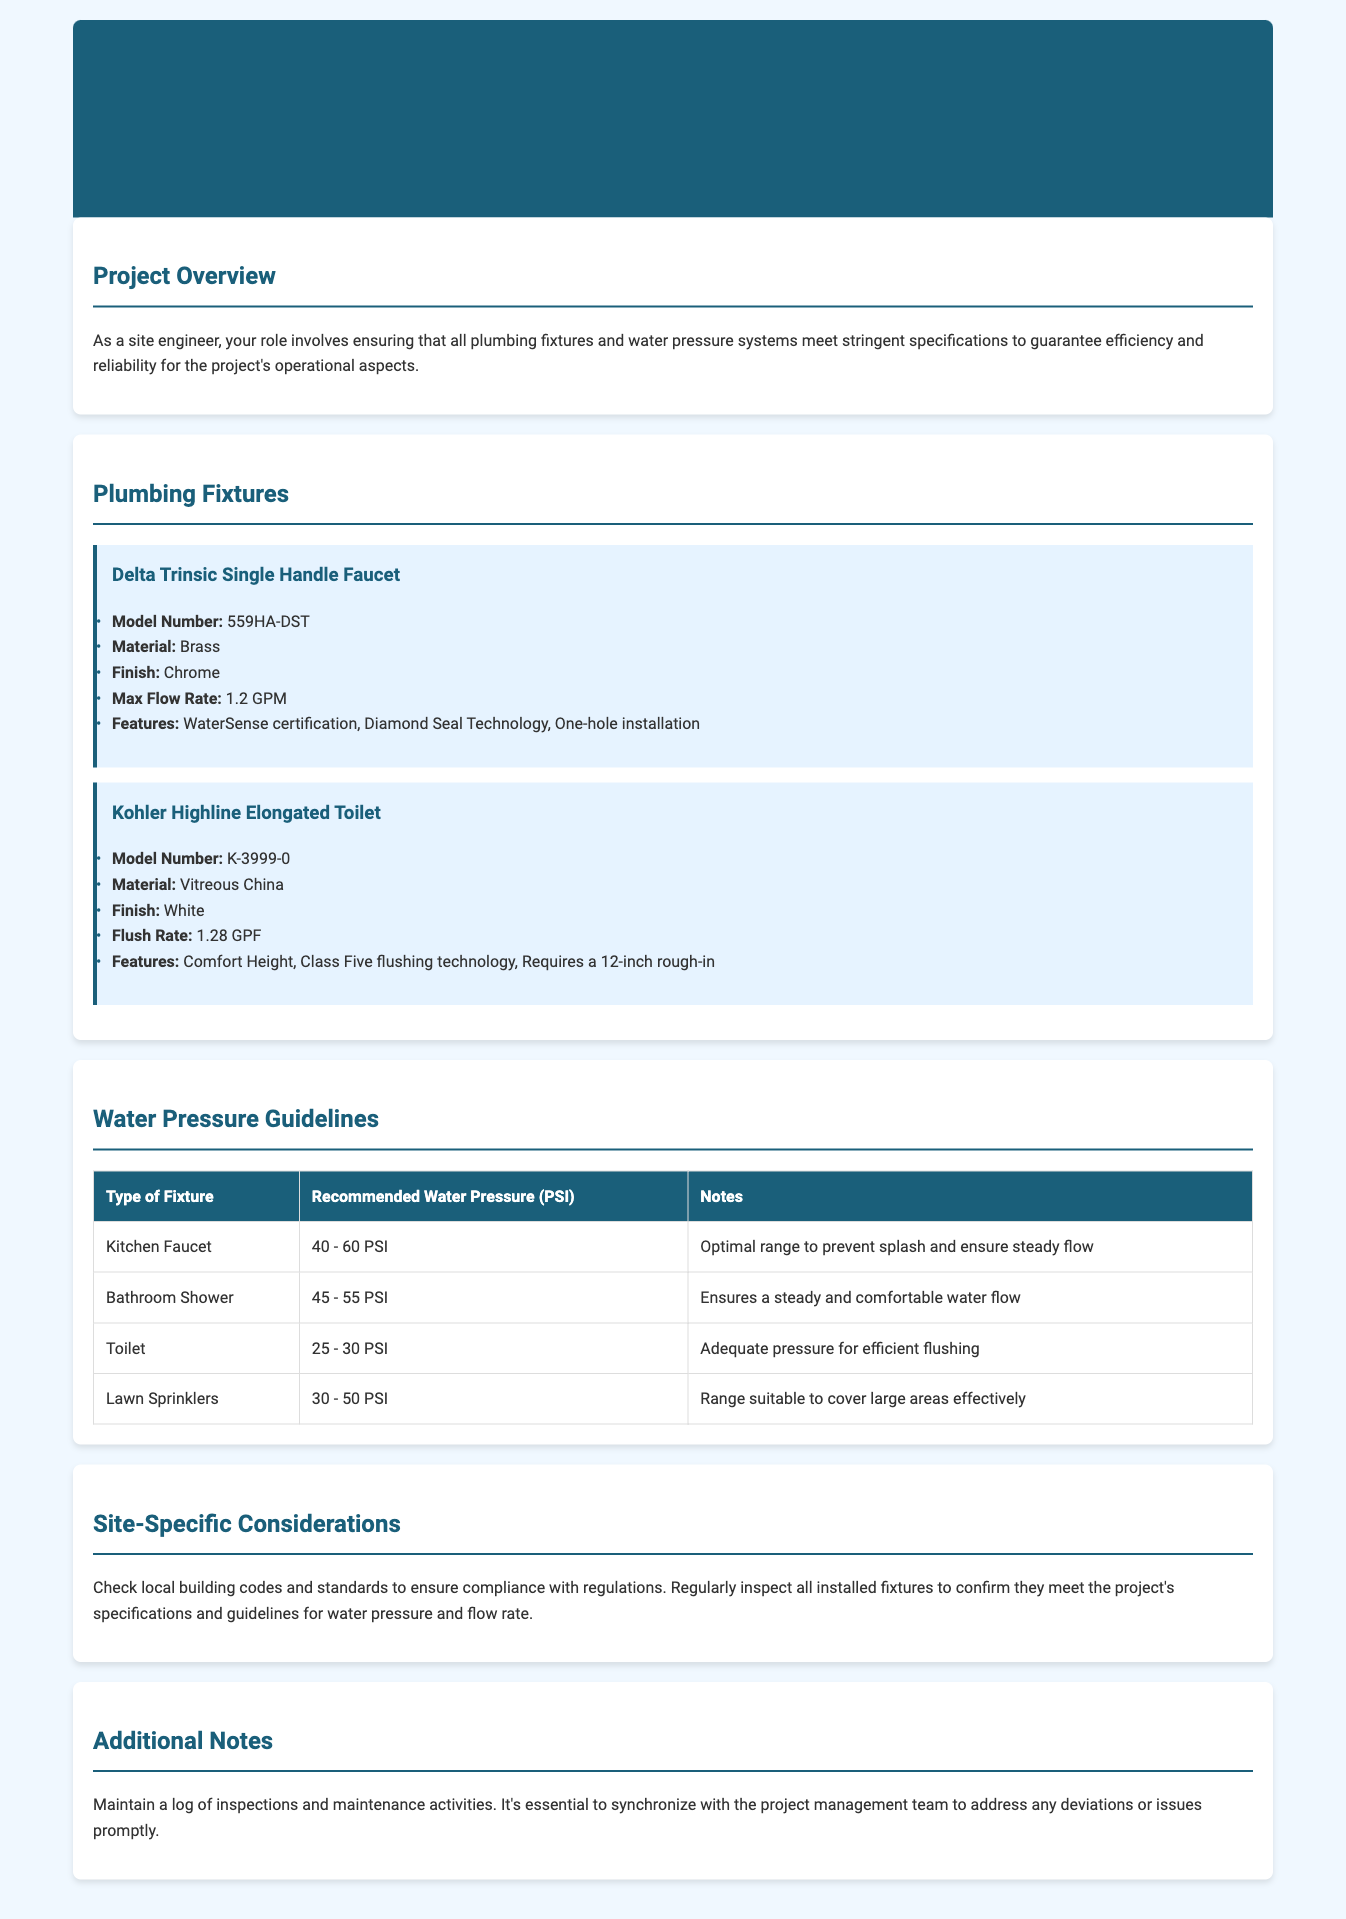What is the model number of the Delta Trinsic Faucet? The model number is listed in the specifications of the Delta Trinsic Single Handle Faucet section.
Answer: 559HA-DST What is the maximum flow rate of the Kohler Highline Toilet? The maximum flow rate is mentioned under the flush specifications of the Kohler Highline Elongated Toilet section.
Answer: 1.28 GPF What is the recommended water pressure for a Kitchen Faucet? The recommended water pressure is outlined in the Water Pressure Guidelines table for each type of fixture.
Answer: 40 - 60 PSI What is the material of the Delta Trinsic Faucet? The material is indicated in the specifications of the Delta Trinsic Single Handle Faucet.
Answer: Brass How many PSI is adequate for flushing a Toilet? Adequate pressure for efficient flushing is specified in the Water Pressure Guidelines section.
Answer: 25 - 30 PSI What is the comfort height feature related to? The comfort height feature is a specification related to the Kohler Highline Elongated Toilet, enhancing usability.
Answer: Toilet What technology does the Delta Trinsic Faucet feature? The technology is among the key features highlighted in the Delta Trinsic Single Handle Faucet specifications.
Answer: Diamond Seal Technology What should you check concerning local building codes? The document emphasizes the importance of checking compliance with regulations and standards according to local laws.
Answer: Compliance What is the main purpose of maintaining a log of inspections? The document suggests this as a best practice for site engineers to track ongoing maintenance and address any issues.
Answer: Maintenance 